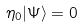<formula> <loc_0><loc_0><loc_500><loc_500>\eta _ { 0 } | \Psi \rangle = 0</formula> 